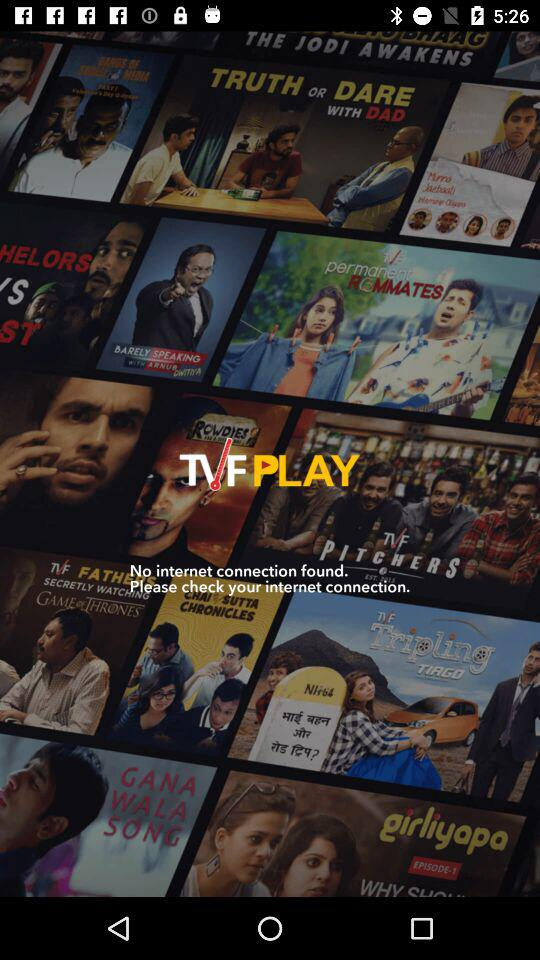What is the name of the application? The application name is "TVF PLAY". 